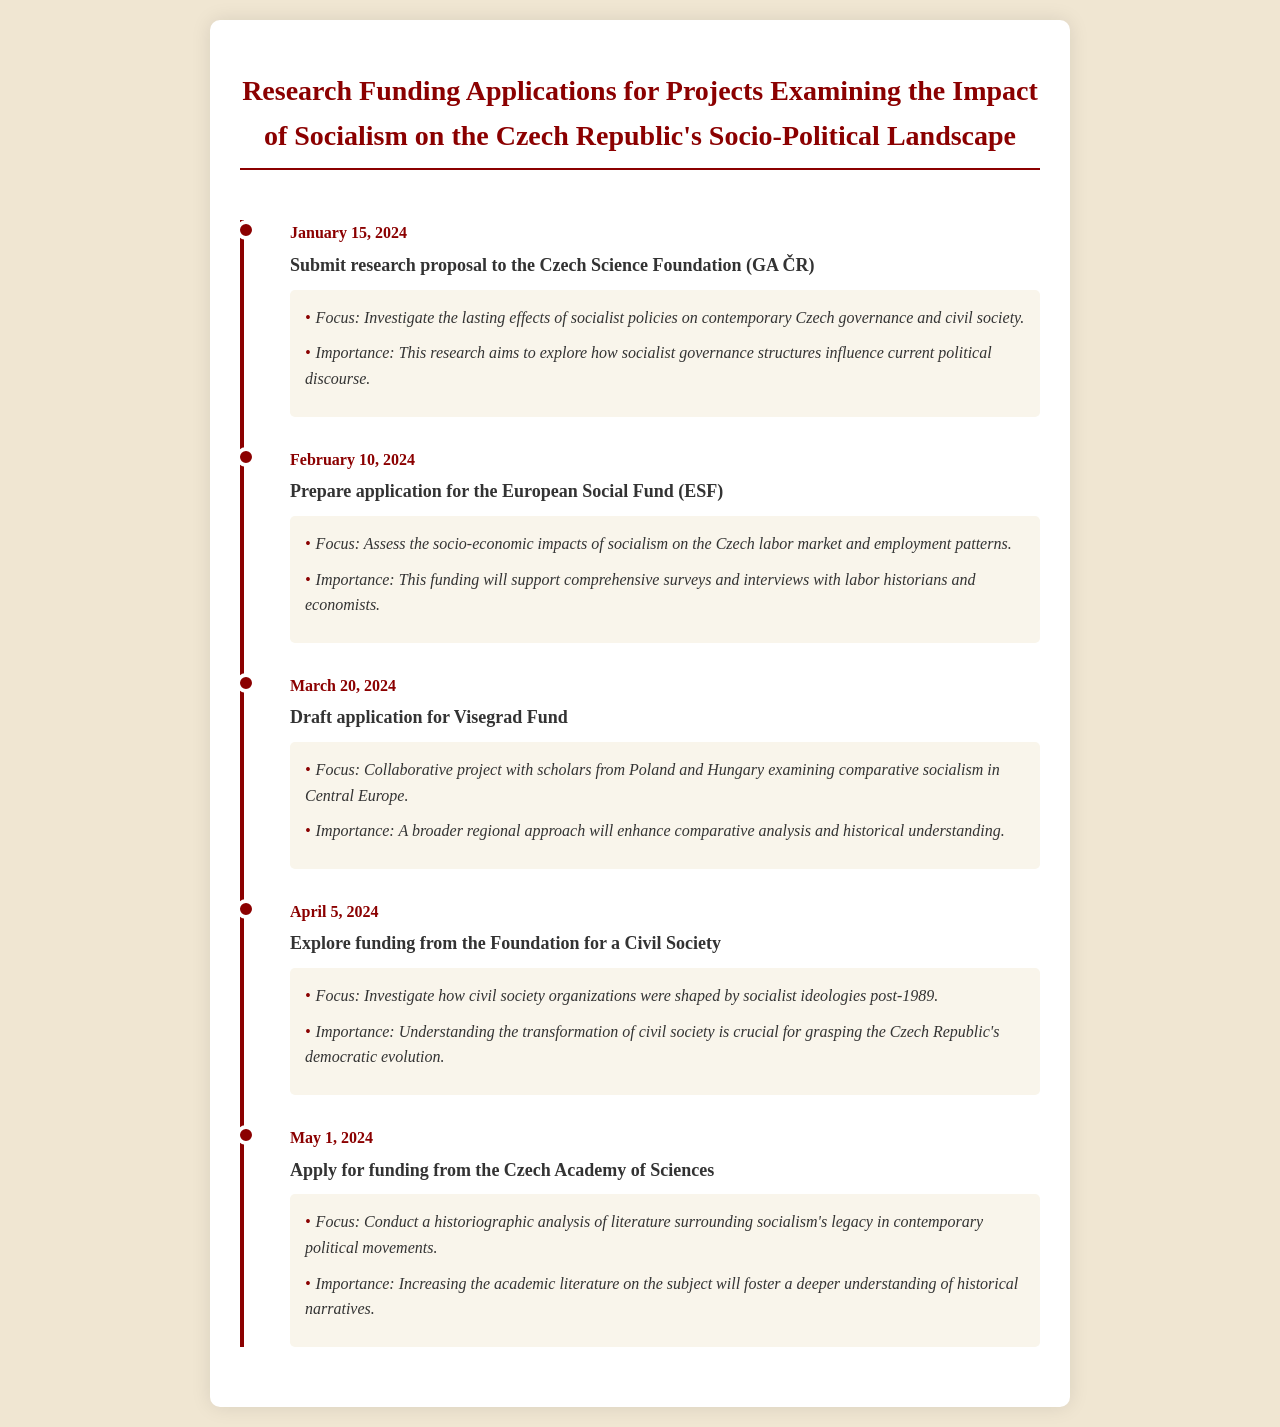what is the first submission date for a research proposal? The first submission date for a research proposal is indicated at the beginning of the timeline section of the document.
Answer: January 15, 2024 what is the focus of the application to the European Social Fund? The focus is listed under the event details for the European Social Fund application in the document.
Answer: Assess the socio-economic impacts of socialism on the Czech labor market and employment patterns how many funding sources are mentioned in the document? The number of funding sources can be counted by reviewing each funding-related event in the timeline.
Answer: Five what is the title of the event scheduled for April 5, 2024? The title can be found next to its corresponding date in the timeline section.
Answer: Explore funding from the Foundation for a Civil Society what is the importance of the draft application for the Visegrad Fund? The importance is detailed in the event's description and highlights the relevance of this project.
Answer: A broader regional approach will enhance comparative analysis and historical understanding what type of analysis is proposed for the funding from the Czech Academy of Sciences? The type of analysis is explained under the event details for the Czech Academy of Sciences funding application.
Answer: Historiographic analysis what is the focus of the first event listed in the document? The focus can be found in the event details for the first event listed, which describes the main purpose of the research proposal.
Answer: Investigate the lasting effects of socialist policies on contemporary Czech governance and civil society which organization is associated with the final funding application date? The organization is identified in the title of the last event mentioned in the document.
Answer: Czech Academy of Sciences 